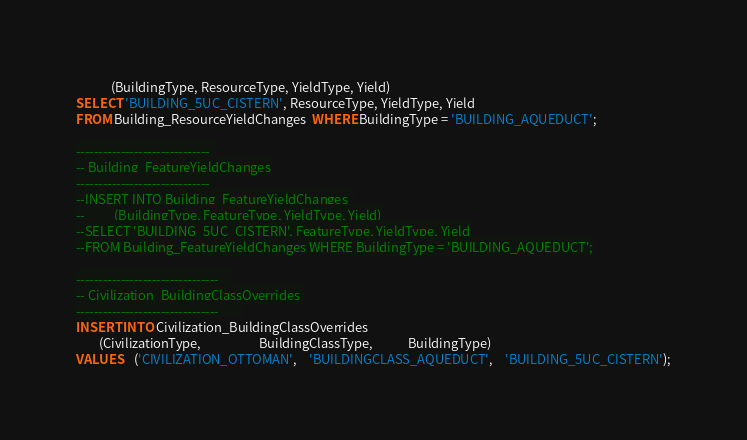<code> <loc_0><loc_0><loc_500><loc_500><_SQL_>			(BuildingType, ResourceType, YieldType, Yield)
SELECT 'BUILDING_5UC_CISTERN', ResourceType, YieldType, Yield
FROM Building_ResourceYieldChanges  WHERE BuildingType = 'BUILDING_AQUEDUCT';

------------------------------	
-- Building_FeatureYieldChanges
------------------------------
--INSERT INTO Building_FeatureYieldChanges 	
--			(BuildingType, FeatureType, YieldType, Yield)
--SELECT 'BUILDING_5UC_CISTERN', FeatureType, YieldType, Yield
--FROM Building_FeatureYieldChanges WHERE BuildingType = 'BUILDING_AQUEDUCT';

--------------------------------	
-- Civilization_BuildingClassOverrides 
--------------------------------		
INSERT INTO Civilization_BuildingClassOverrides 
		(CivilizationType, 					BuildingClassType, 			BuildingType)
VALUES	('CIVILIZATION_OTTOMAN',	'BUILDINGCLASS_AQUEDUCT',	'BUILDING_5UC_CISTERN');

</code> 